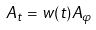Convert formula to latex. <formula><loc_0><loc_0><loc_500><loc_500>A _ { t } = w ( t ) A _ { \varphi }</formula> 